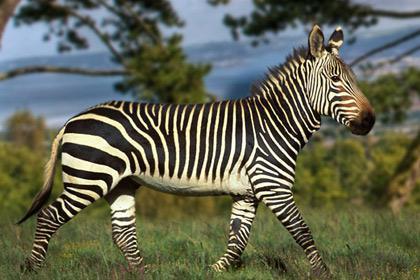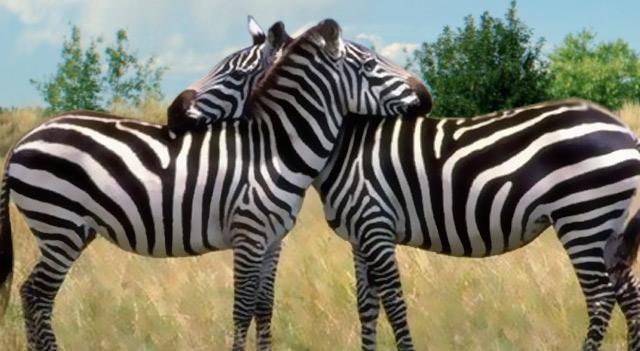The first image is the image on the left, the second image is the image on the right. For the images shown, is this caption "The left image contains no more than one zebra." true? Answer yes or no. Yes. The first image is the image on the left, the second image is the image on the right. Considering the images on both sides, is "One image shows two zebra standing in profile turned toward one another, each one with its head over the back of the other." valid? Answer yes or no. Yes. 